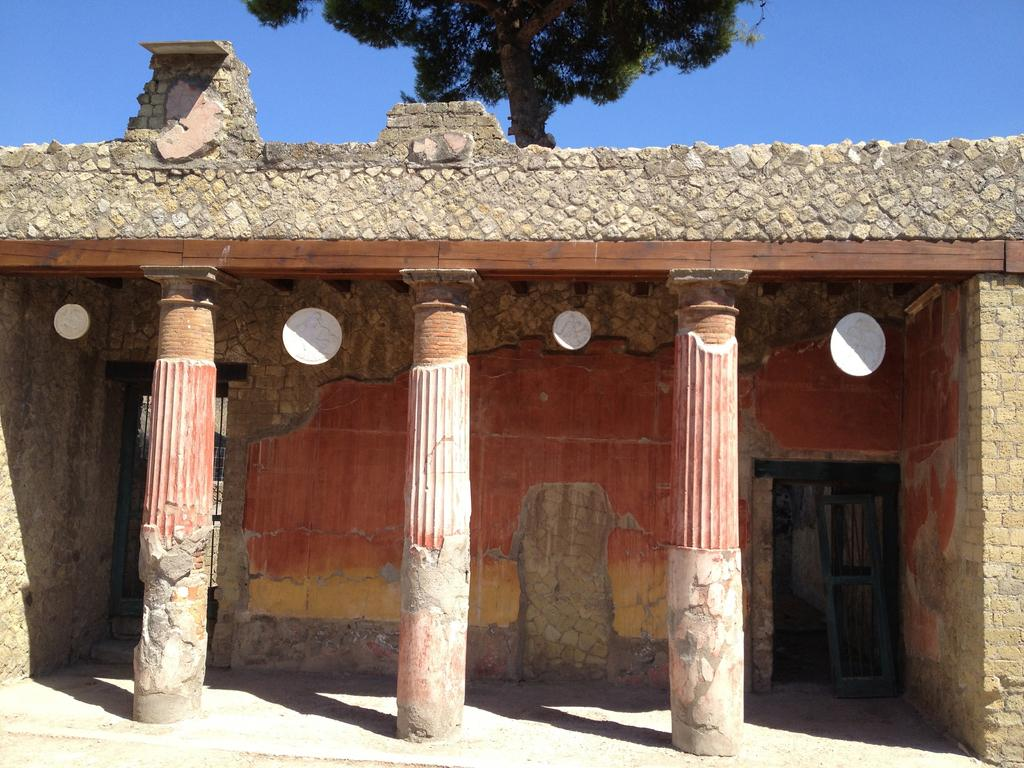What type of structure is in the foreground of the image? There is an old building in the foreground of the image. What architectural features can be seen on the building? The building has three pillars and a wall. Does the building have an entrance? Yes, there is a door on the building. What can be seen in the background of the image? There is a tree and the sky visible in the background of the image. What type of ink can be seen dripping from the tree in the image? There is no ink present in the image; it features an old building with a tree and the sky in the background. 